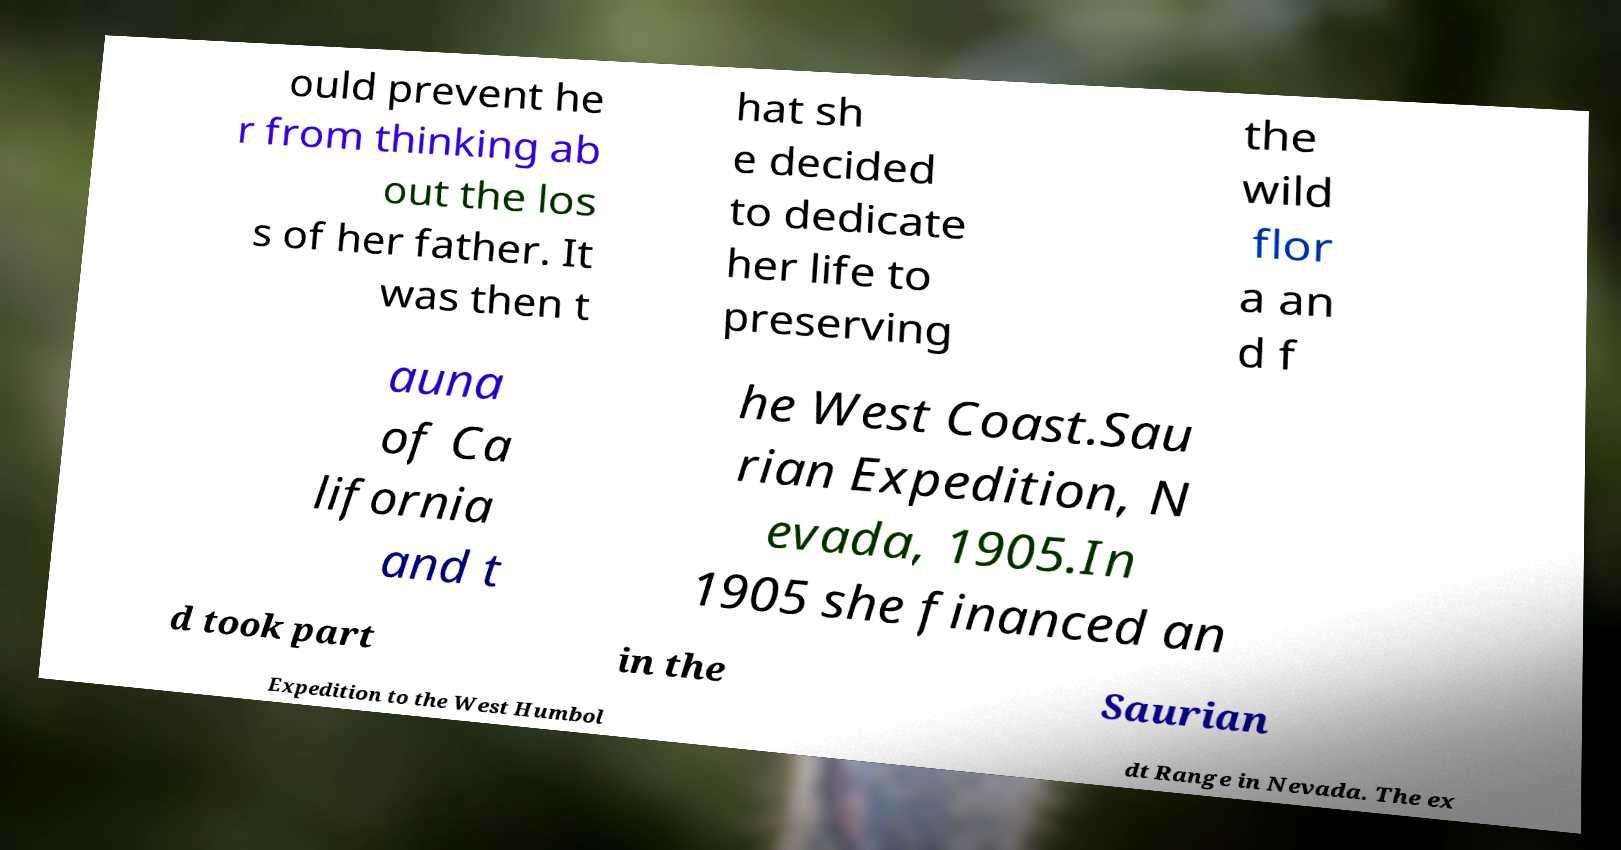There's text embedded in this image that I need extracted. Can you transcribe it verbatim? ould prevent he r from thinking ab out the los s of her father. It was then t hat sh e decided to dedicate her life to preserving the wild flor a an d f auna of Ca lifornia and t he West Coast.Sau rian Expedition, N evada, 1905.In 1905 she financed an d took part in the Saurian Expedition to the West Humbol dt Range in Nevada. The ex 